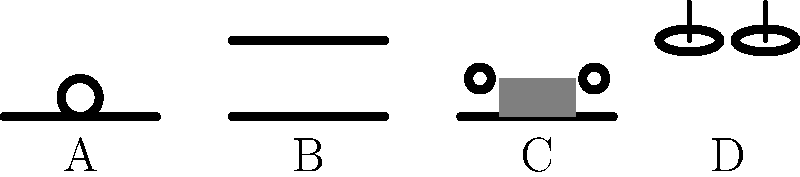As a former gymnast, you're familiar with various apparatus used in men's artistic gymnastics. Based on the shapes and features shown in the diagram, which apparatus is represented by label C? To answer this question, let's analyze the features of each apparatus shown in the diagram:

1. Apparatus A: This shows a horizontal bar with a circle above it, representing the high bar used in men's artistic gymnastics.

2. Apparatus B: This depicts two parallel horizontal bars, clearly representing the parallel bars.

3. Apparatus C: This apparatus shows a horizontal base with a rectangular shape on top and two small circles at each end. This unique configuration represents the pommel horse, which has a long body (the rectangle) and two pommels (the circles) that gymnasts grip during their routines.

4. Apparatus D: This shows two oval shapes suspended by cables, which represents the rings used in men's gymnastics.

Given the question asks about label C, we can confidently identify this as the pommel horse based on its distinctive shape with the long body and two pommels at the ends.
Answer: Pommel horse 